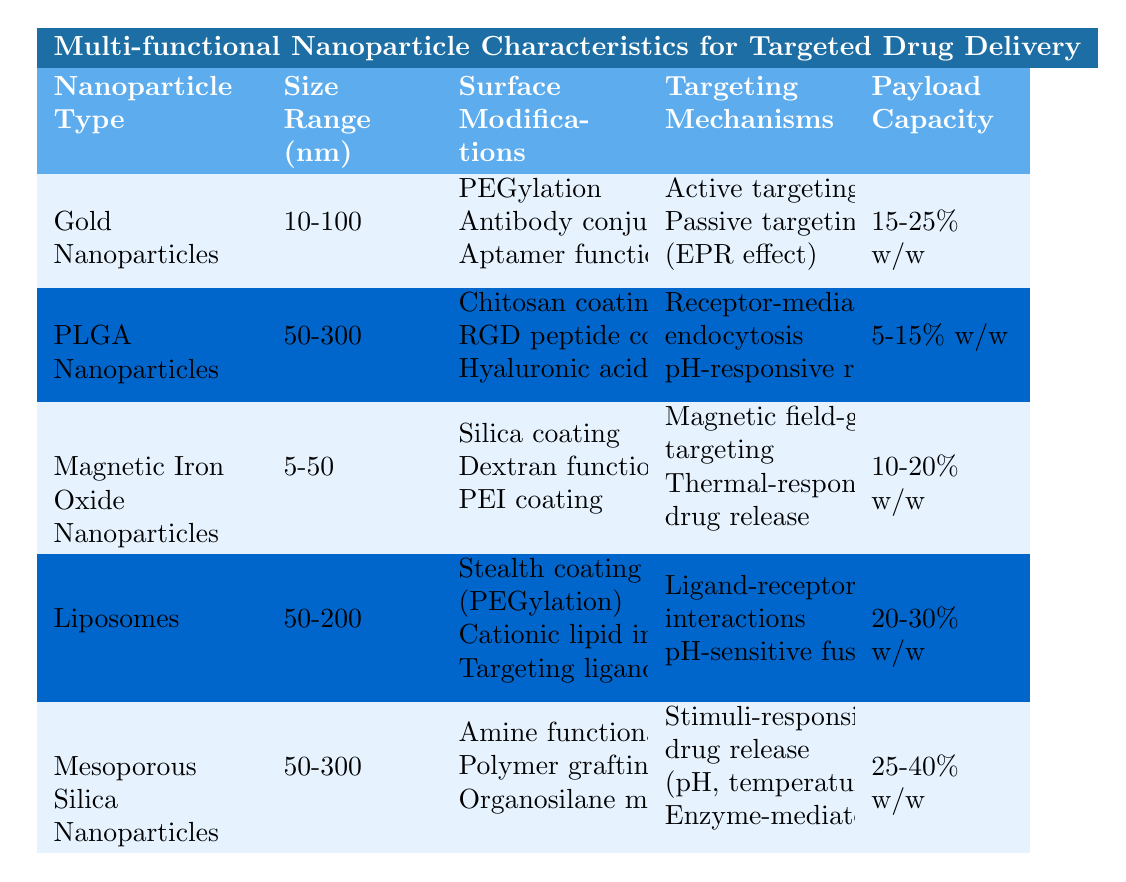What is the size range of Gold Nanoparticles? According to the table, Gold Nanoparticles have a size range of 10-100 nm.
Answer: 10-100 nm Which nanoparticle type has the highest payload capacity? The table lists Mesoporous Silica Nanoparticles with a payload capacity of 25-40% w/w, which is higher than others.
Answer: Mesoporous Silica Nanoparticles Are Liposomes modified with cationic lipids? The table indicates that Liposomes have an additional surface modification of cationic lipid incorporation, which confirms the statement.
Answer: Yes What are the targeting mechanisms for PLGA Nanoparticles? PLGA Nanoparticles employ receptor-mediated endocytosis and pH-responsive release as their targeting mechanisms, as per the table.
Answer: Receptor-mediated endocytosis, pH-responsive release Which nanoparticle has active targeting among its mechanisms? The table shows that Gold Nanoparticles are associated with active targeting, fulfilling this requirement.
Answer: Gold Nanoparticles What is the average payload capacity of the nanoparticle types listed? To calculate the average, we first identify the payload capacities: 20%, 10%, 15%, 25%, and 30%. The average is calculated as (15+10+20+30+25)/5 = 18%.
Answer: 18% Can Mesoporous Silica Nanoparticles be applied for gene delivery? The table lists gene delivery for tissue engineering as one of the applications for Mesoporous Silica Nanoparticles, making the statement true.
Answer: Yes Which nanoparticle types utilize passive targeting? Gold Nanoparticles utilize passive targeting (EPR effect), according to the table. Thus, Gold is the answer.
Answer: Gold Nanoparticles How does the size range of Magnetic Iron Oxide Nanoparticles compare to that of PLGA Nanoparticles? Magnetic Iron Oxide Nanoparticles have a size range of 5-50 nm, whereas PLGA Nanoparticles range from 50-300 nm. PLGA Nanoparticles are larger in size.
Answer: PLGA Nanoparticles are larger What is the common surface modification between Gold Nanoparticles and Liposomes? Both Gold Nanoparticles and Liposomes are modified with PEGylation as a surface modification, as noted in the table.
Answer: PEGylation 